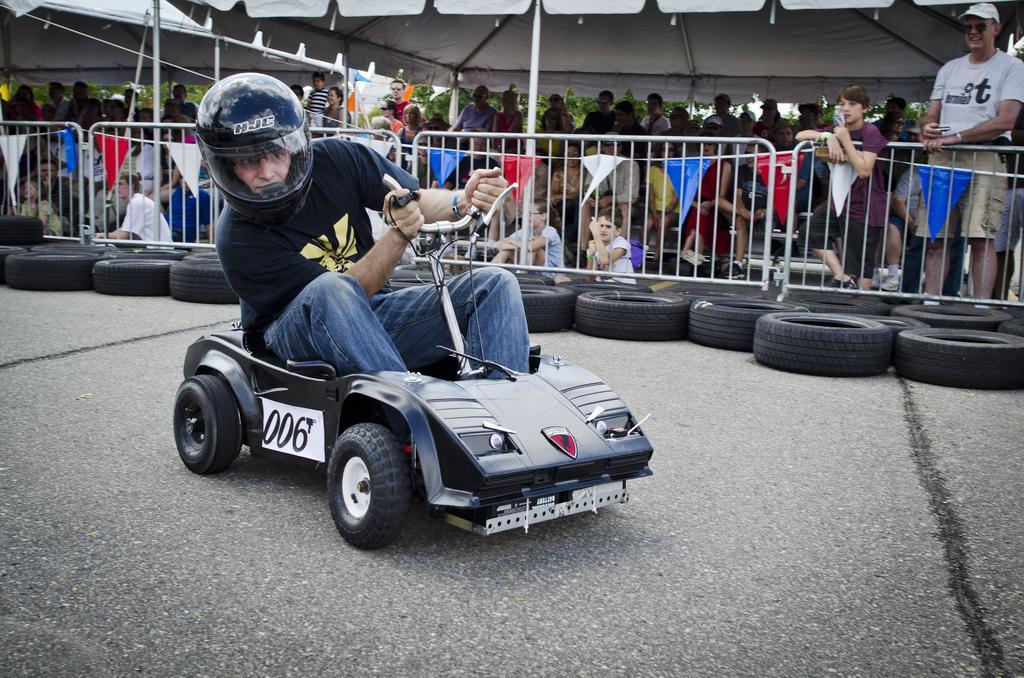In one or two sentences, can you explain what this image depicts? In this picture we can see a man wore a helmet and riding a vehicle on the road, tyres, fence, flags, tents and a group of people standing and in the background we can see trees. 